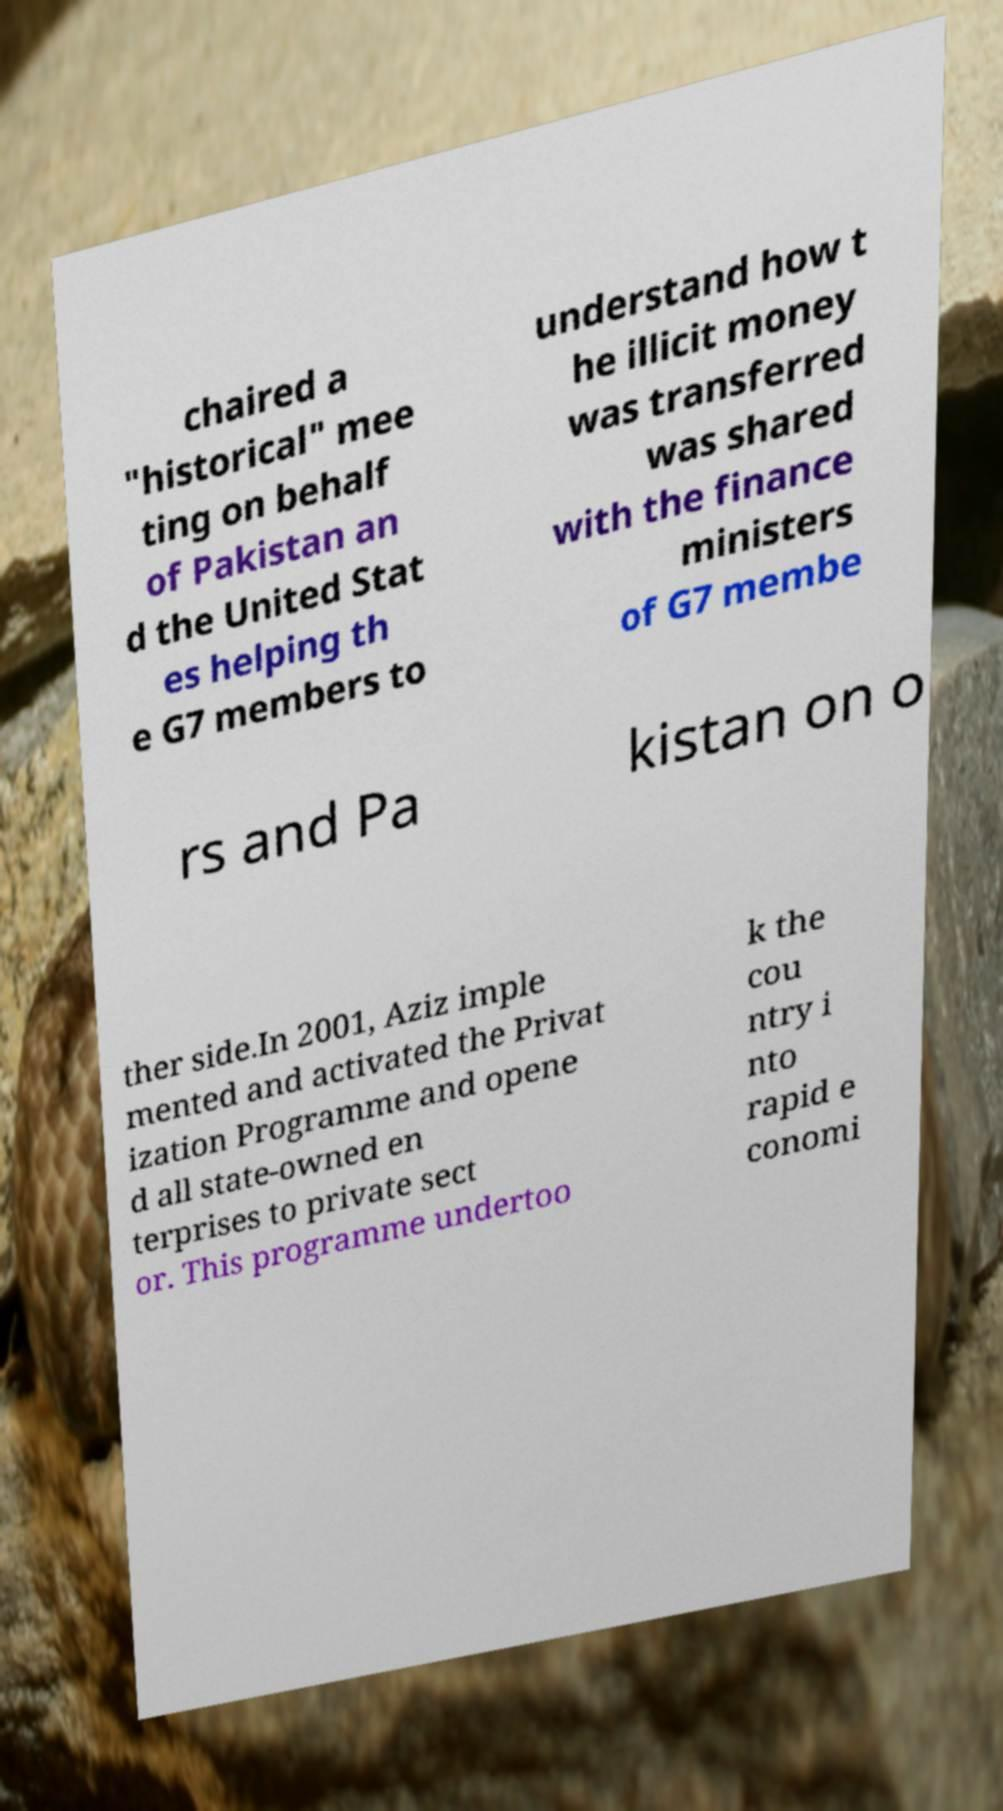Could you assist in decoding the text presented in this image and type it out clearly? chaired a "historical" mee ting on behalf of Pakistan an d the United Stat es helping th e G7 members to understand how t he illicit money was transferred was shared with the finance ministers of G7 membe rs and Pa kistan on o ther side.In 2001, Aziz imple mented and activated the Privat ization Programme and opene d all state-owned en terprises to private sect or. This programme undertoo k the cou ntry i nto rapid e conomi 